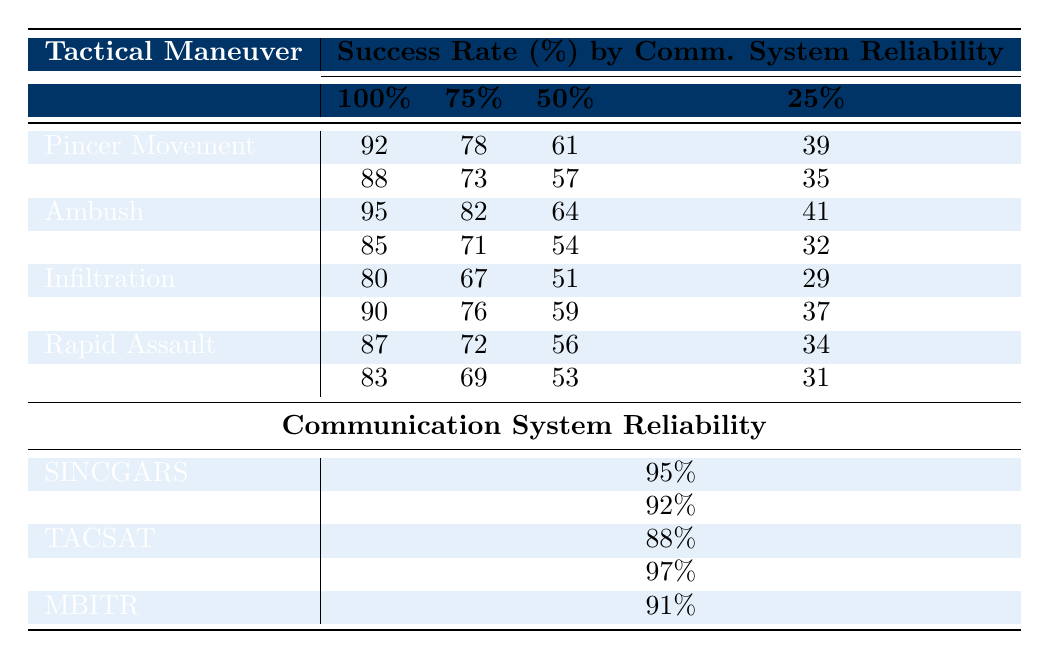What is the success rate of the Ambush maneuver at 100% communication system reliability? In the table, the success rate of the Ambush maneuver is directly listed as 95% for the 100% reliability level.
Answer: 95% Which maneuver has the lowest success rate at 25% communication system reliability? Looking at the table, the lowest success rate at the 25% reliability level is 29%, which corresponds to the Infiltration maneuver.
Answer: Infiltration What is the difference in success rates between the Pincer Movement and Flanking Attack at 50% communication system reliability? The success rate for the Pincer Movement at 50% reliability is 61%, and the Flanking Attack is 57%. The difference is 61% - 57% = 4%.
Answer: 4% Is the success rate of Rapid Assault higher than that of Guerrilla Tactics at 75% communication system reliability? For Rapid Assault, the success rate at 75% is 72%, while for Guerrilla Tactics, it is 69%. Since 72% is greater than 69%, the statement is true.
Answer: Yes What is the average success rate across all maneuvers at 100% communication system reliability? To find the average, sum the success rates at 100%: (92 + 88 + 95 + 85 + 80 + 90 + 87 + 83) = 720. There are 8 maneuvers, so the average is 720 / 8 = 90%.
Answer: 90% Which communication system has the highest reliability, and what is its reliability percentage? From the communication systems listed, SATCOM has the highest reliability at 97%.
Answer: SATCOM, 97% If we consider only maneuvers with a success rate above 85% at 75% reliability, which maneuvers qualify? By examining the 75% success rates: Pincer Movement (78%), Flanking Attack (73%), Ambush (82%), Feigned Retreat (71%), Infiltration (67%), Encirclement (76%), Rapid Assault (72%), Guerrilla Tactics (69%). Only Ambush (82%) and Encirclement (76%) exceed 85%.
Answer: Ambush, Encirclement What is the total reliability percentage for all communication systems listed? The total reliability is calculated by summing the individual reliabilities: 95 + 92 + 88 + 97 + 91 = 463.
Answer: 463 Which tactical maneuver has the best overall performance based on the highest success rate at any reliability level? Reviewing the success rates, Ambush has the highest success rate at 100% reliability with 95%.
Answer: Ambush If the success rate of Flanking Attack were to increase by 5% uniformly across all reliability levels, what would the new success rates be? The original success rates for Flanking Attack are 88%, 73%, 57%, and 35%. Adding 5% gives: 93%, 78%, 62%, and 40%.
Answer: 93%, 78%, 62%, 40% 